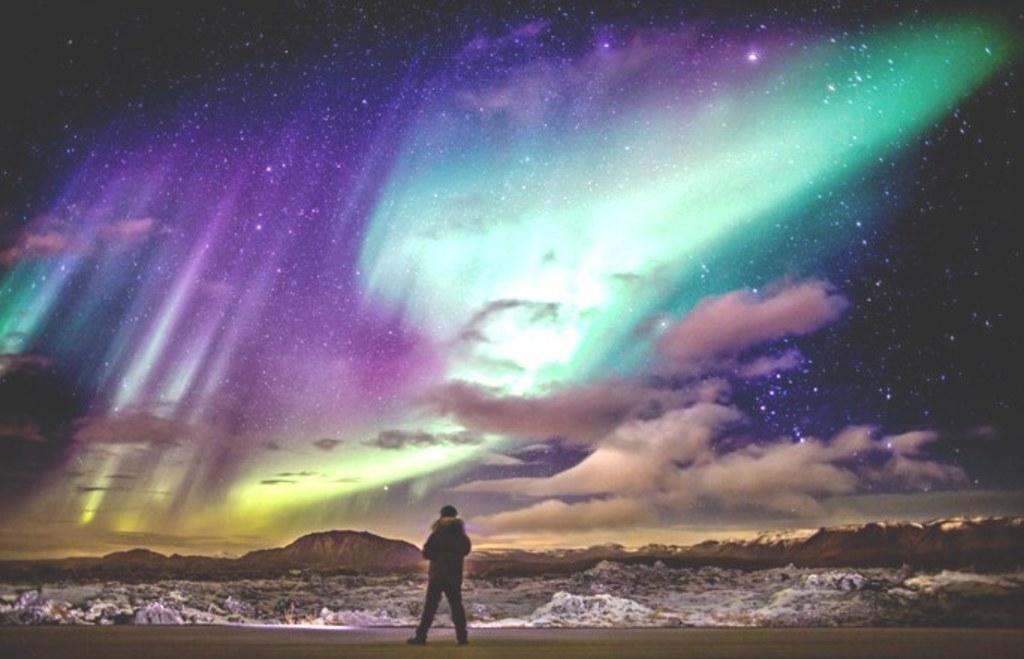How would you summarize this image in a sentence or two? In the foreground of the pictures there is a person standing. In the center of the picture there are mountains and the other objects looking like trees. At the top there are northern lights in the sky and there are stars and clouds. 